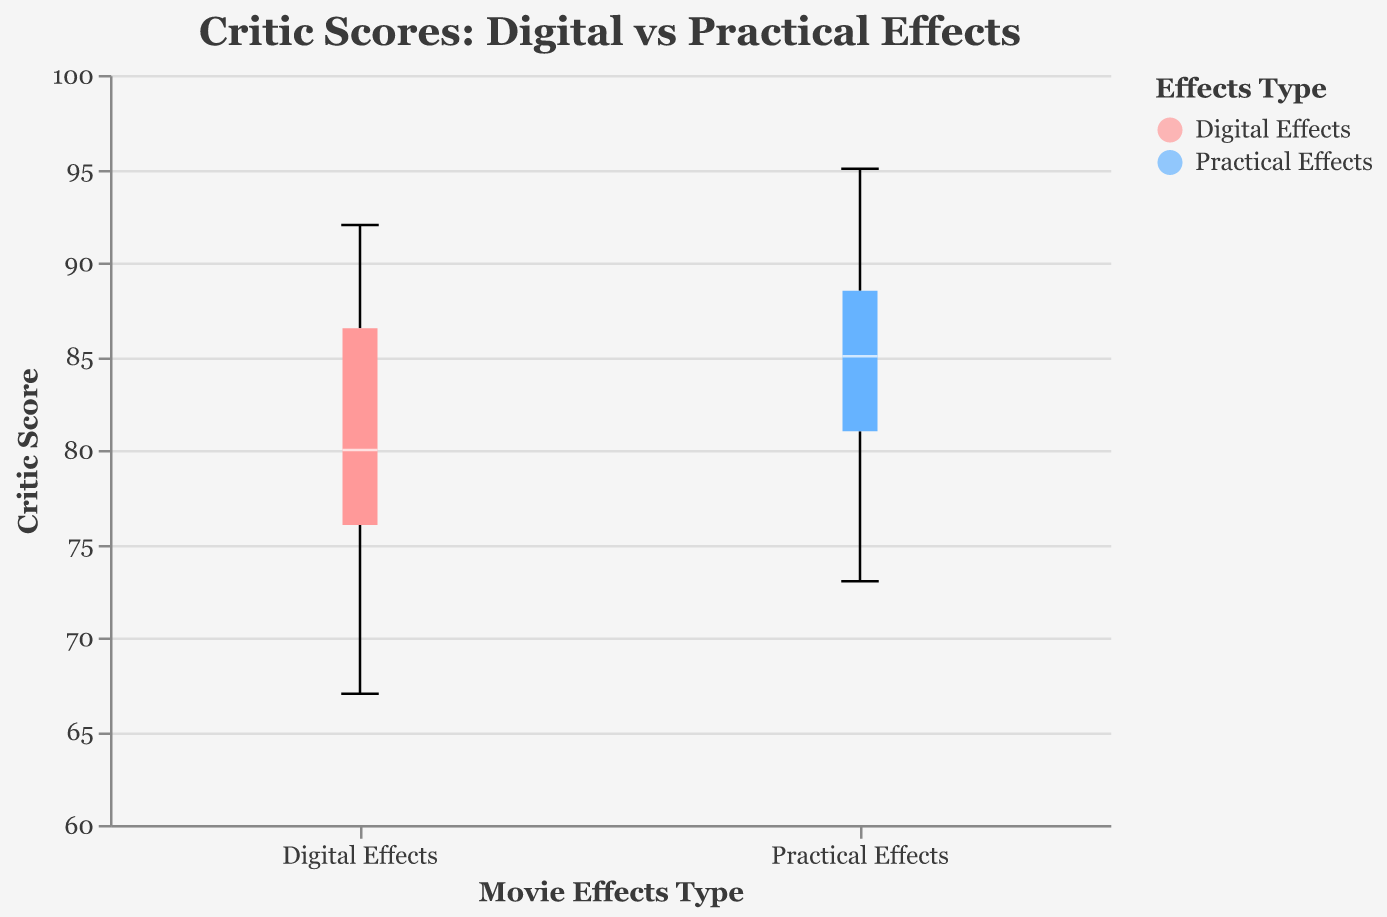what is the title of the plot? The title of the plot is located at the top area of the visual representation and it reads "Critic Scores: Digital vs Practical Effects."
Answer: Critic Scores: Digital vs Practical Effects How many types of movie effects are compared in the plot? There are two types of movie effects compared in the plot, visible on the x-axis labels: "Digital Effects" and "Practical Effects."
Answer: Two What is the color used for "Digital Effects"? The color used for "Digital Effects" can be seen in the legend and the box plot itself, which is shown in a shade of red.
Answer: Red What is the color used for "Practical Effects"? The color used for "Practical Effects" is visible in the legend and the box plot, exhibited in a shade of blue.
Answer: Blue What is the range of critic scores for movies with digital effects? By observing the whiskers of the box plot for digital effects, the lowest and highest points indicate the range.
Answer: 67-92 What is the range of critic scores for movies with practical effects? The range is determined by the whiskers of the box plot for practical effects, indicating the lowest and highest scores.
Answer: 73-95 What is the median critic score for "Digital Effects"? The median is represented by the line within the box of the "Digital Effects" box plot, seen as a central division.
Answer: 80 What is the median critic score for "Practical Effects"? The median is indicated by the line within the box of the "Practical Effects" box plot, showcased near the middle.
Answer: 86 Which type of effect has the higher median critic score? By comparing the median lines of both box plots, the one with "Practical Effects" is higher than "Digital Effects."
Answer: Practical Effects Which type of effect exhibits a higher variability in critic scores? Variability is assessed by looking at the interquartile ranges and the lengths of the whiskers in both box plots. "Practical Effects" shows a wider spread.
Answer: Practical Effects 